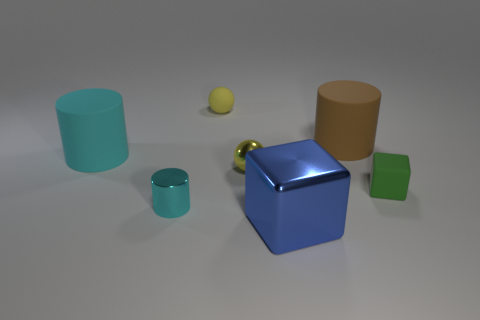How many cyan things are in front of the big cyan cylinder?
Provide a short and direct response. 1. Are there any matte blocks that have the same size as the metallic cylinder?
Provide a short and direct response. Yes. Do the small matte sphere and the metal sphere have the same color?
Ensure brevity in your answer.  Yes. There is a big object on the left side of the tiny matte object that is to the left of the brown matte cylinder; what is its color?
Offer a very short reply. Cyan. What number of objects are on the right side of the tiny yellow matte sphere and in front of the tiny yellow shiny object?
Keep it short and to the point. 2. How many big metal objects have the same shape as the brown rubber object?
Ensure brevity in your answer.  0. Are the tiny cylinder and the big brown thing made of the same material?
Provide a short and direct response. No. There is a big matte object that is to the left of the big cylinder that is on the right side of the blue shiny object; what shape is it?
Ensure brevity in your answer.  Cylinder. There is a tiny yellow sphere that is to the right of the small matte ball; what number of large cylinders are in front of it?
Give a very brief answer. 0. There is a thing that is both in front of the small green cube and behind the blue cube; what is it made of?
Keep it short and to the point. Metal. 